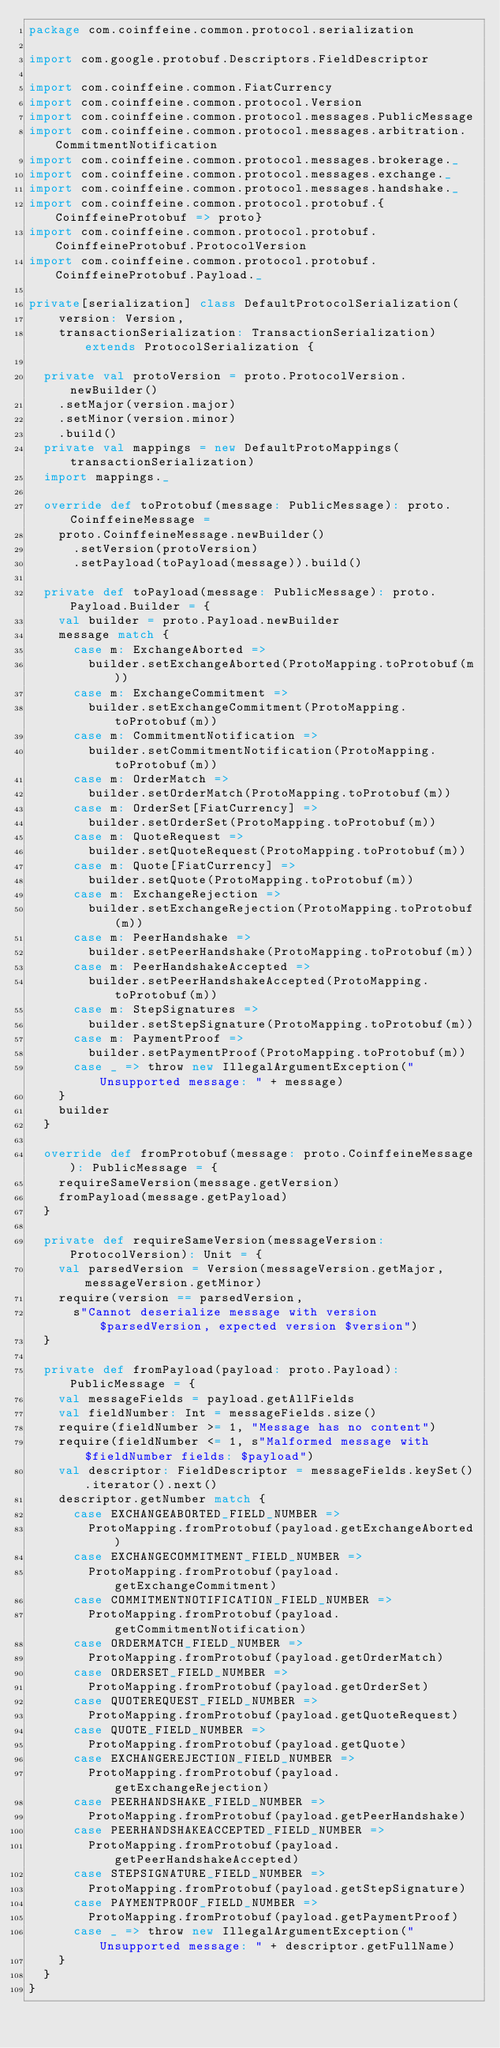Convert code to text. <code><loc_0><loc_0><loc_500><loc_500><_Scala_>package com.coinffeine.common.protocol.serialization

import com.google.protobuf.Descriptors.FieldDescriptor

import com.coinffeine.common.FiatCurrency
import com.coinffeine.common.protocol.Version
import com.coinffeine.common.protocol.messages.PublicMessage
import com.coinffeine.common.protocol.messages.arbitration.CommitmentNotification
import com.coinffeine.common.protocol.messages.brokerage._
import com.coinffeine.common.protocol.messages.exchange._
import com.coinffeine.common.protocol.messages.handshake._
import com.coinffeine.common.protocol.protobuf.{CoinffeineProtobuf => proto}
import com.coinffeine.common.protocol.protobuf.CoinffeineProtobuf.ProtocolVersion
import com.coinffeine.common.protocol.protobuf.CoinffeineProtobuf.Payload._

private[serialization] class DefaultProtocolSerialization(
    version: Version,
    transactionSerialization: TransactionSerialization) extends ProtocolSerialization {

  private val protoVersion = proto.ProtocolVersion.newBuilder()
    .setMajor(version.major)
    .setMinor(version.minor)
    .build()
  private val mappings = new DefaultProtoMappings(transactionSerialization)
  import mappings._

  override def toProtobuf(message: PublicMessage): proto.CoinffeineMessage =
    proto.CoinffeineMessage.newBuilder()
      .setVersion(protoVersion)
      .setPayload(toPayload(message)).build()

  private def toPayload(message: PublicMessage): proto.Payload.Builder = {
    val builder = proto.Payload.newBuilder
    message match {
      case m: ExchangeAborted =>
        builder.setExchangeAborted(ProtoMapping.toProtobuf(m))
      case m: ExchangeCommitment =>
        builder.setExchangeCommitment(ProtoMapping.toProtobuf(m))
      case m: CommitmentNotification =>
        builder.setCommitmentNotification(ProtoMapping.toProtobuf(m))
      case m: OrderMatch =>
        builder.setOrderMatch(ProtoMapping.toProtobuf(m))
      case m: OrderSet[FiatCurrency] =>
        builder.setOrderSet(ProtoMapping.toProtobuf(m))
      case m: QuoteRequest =>
        builder.setQuoteRequest(ProtoMapping.toProtobuf(m))
      case m: Quote[FiatCurrency] =>
        builder.setQuote(ProtoMapping.toProtobuf(m))
      case m: ExchangeRejection =>
        builder.setExchangeRejection(ProtoMapping.toProtobuf(m))
      case m: PeerHandshake =>
        builder.setPeerHandshake(ProtoMapping.toProtobuf(m))
      case m: PeerHandshakeAccepted =>
        builder.setPeerHandshakeAccepted(ProtoMapping.toProtobuf(m))
      case m: StepSignatures =>
        builder.setStepSignature(ProtoMapping.toProtobuf(m))
      case m: PaymentProof =>
        builder.setPaymentProof(ProtoMapping.toProtobuf(m))
      case _ => throw new IllegalArgumentException("Unsupported message: " + message)
    }
    builder
  }

  override def fromProtobuf(message: proto.CoinffeineMessage): PublicMessage = {
    requireSameVersion(message.getVersion)
    fromPayload(message.getPayload)
  }

  private def requireSameVersion(messageVersion: ProtocolVersion): Unit = {
    val parsedVersion = Version(messageVersion.getMajor, messageVersion.getMinor)
    require(version == parsedVersion,
      s"Cannot deserialize message with version $parsedVersion, expected version $version")
  }

  private def fromPayload(payload: proto.Payload): PublicMessage = {
    val messageFields = payload.getAllFields
    val fieldNumber: Int = messageFields.size()
    require(fieldNumber >= 1, "Message has no content")
    require(fieldNumber <= 1, s"Malformed message with $fieldNumber fields: $payload")
    val descriptor: FieldDescriptor = messageFields.keySet().iterator().next()
    descriptor.getNumber match {
      case EXCHANGEABORTED_FIELD_NUMBER =>
        ProtoMapping.fromProtobuf(payload.getExchangeAborted)
      case EXCHANGECOMMITMENT_FIELD_NUMBER =>
        ProtoMapping.fromProtobuf(payload.getExchangeCommitment)
      case COMMITMENTNOTIFICATION_FIELD_NUMBER =>
        ProtoMapping.fromProtobuf(payload.getCommitmentNotification)
      case ORDERMATCH_FIELD_NUMBER =>
        ProtoMapping.fromProtobuf(payload.getOrderMatch)
      case ORDERSET_FIELD_NUMBER =>
        ProtoMapping.fromProtobuf(payload.getOrderSet)
      case QUOTEREQUEST_FIELD_NUMBER =>
        ProtoMapping.fromProtobuf(payload.getQuoteRequest)
      case QUOTE_FIELD_NUMBER =>
        ProtoMapping.fromProtobuf(payload.getQuote)
      case EXCHANGEREJECTION_FIELD_NUMBER =>
        ProtoMapping.fromProtobuf(payload.getExchangeRejection)
      case PEERHANDSHAKE_FIELD_NUMBER =>
        ProtoMapping.fromProtobuf(payload.getPeerHandshake)
      case PEERHANDSHAKEACCEPTED_FIELD_NUMBER =>
        ProtoMapping.fromProtobuf(payload.getPeerHandshakeAccepted)
      case STEPSIGNATURE_FIELD_NUMBER =>
        ProtoMapping.fromProtobuf(payload.getStepSignature)
      case PAYMENTPROOF_FIELD_NUMBER =>
        ProtoMapping.fromProtobuf(payload.getPaymentProof)
      case _ => throw new IllegalArgumentException("Unsupported message: " + descriptor.getFullName)
    }
  }
}
</code> 